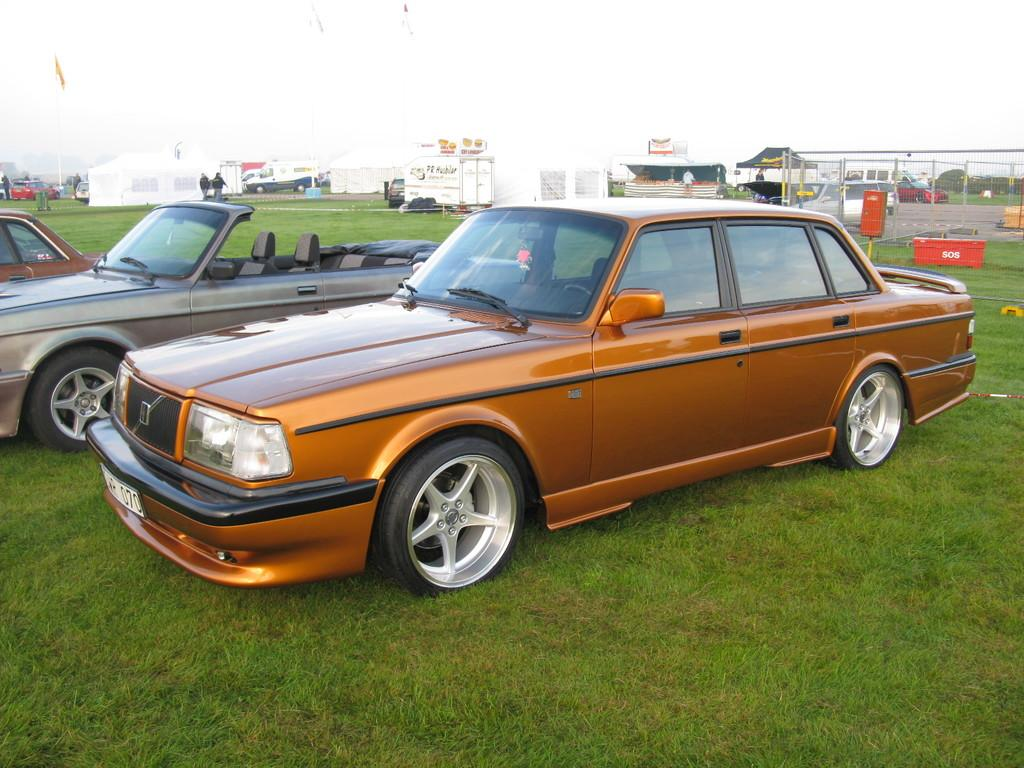What can be seen on the ground in the image? There are vehicles on the ground in the image. What is visible in the background of the image? In the background, there are trees, people, tents, poles, a fence, hoardings, vehicles, and the sky. Can you describe the setting of the image? The image appears to be set in an outdoor area with vehicles, trees, and various structures in the background. Can you see any lips or kissing in the image? There are no lips or kissing visible in the image. What type of rod is being used by the people in the image? There is no rod present in the image; it features vehicles, trees, and various structures in the background. 